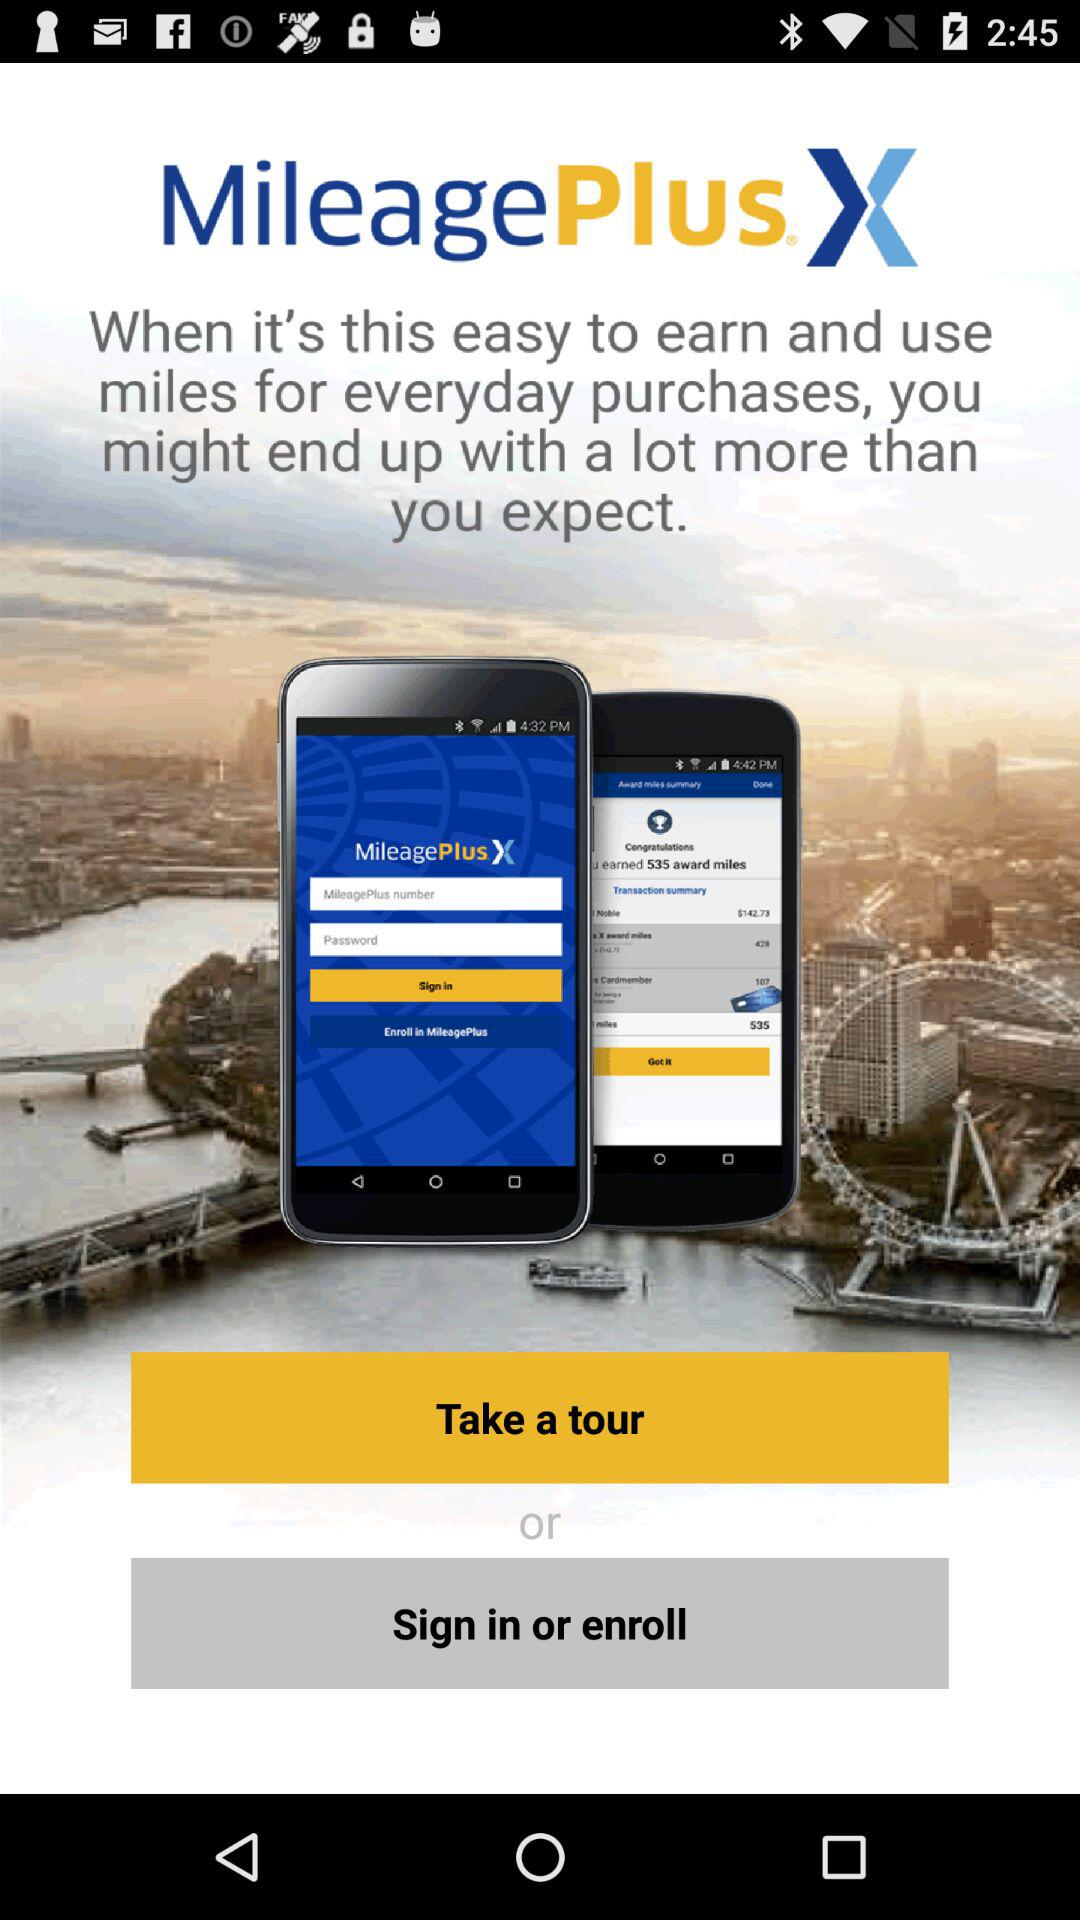What is the name of the application? The name of the application is "MileagePlus X". 